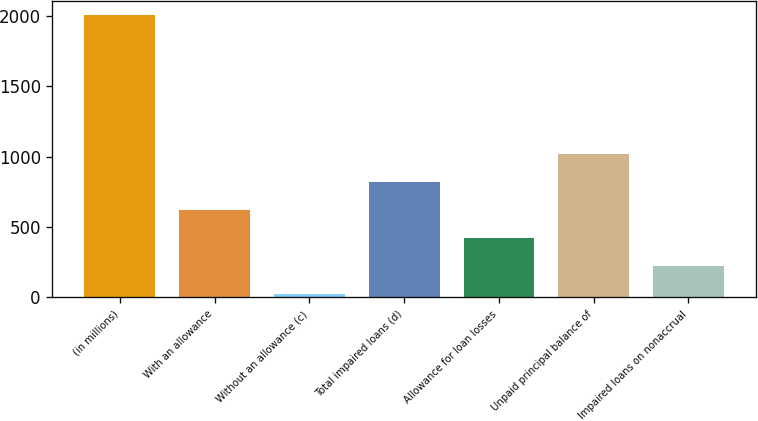Convert chart to OTSL. <chart><loc_0><loc_0><loc_500><loc_500><bar_chart><fcel>(in millions)<fcel>With an allowance<fcel>Without an allowance (c)<fcel>Total impaired loans (d)<fcel>Allowance for loan losses<fcel>Unpaid principal balance of<fcel>Impaired loans on nonaccrual<nl><fcel>2010<fcel>620.5<fcel>25<fcel>819<fcel>422<fcel>1017.5<fcel>223.5<nl></chart> 